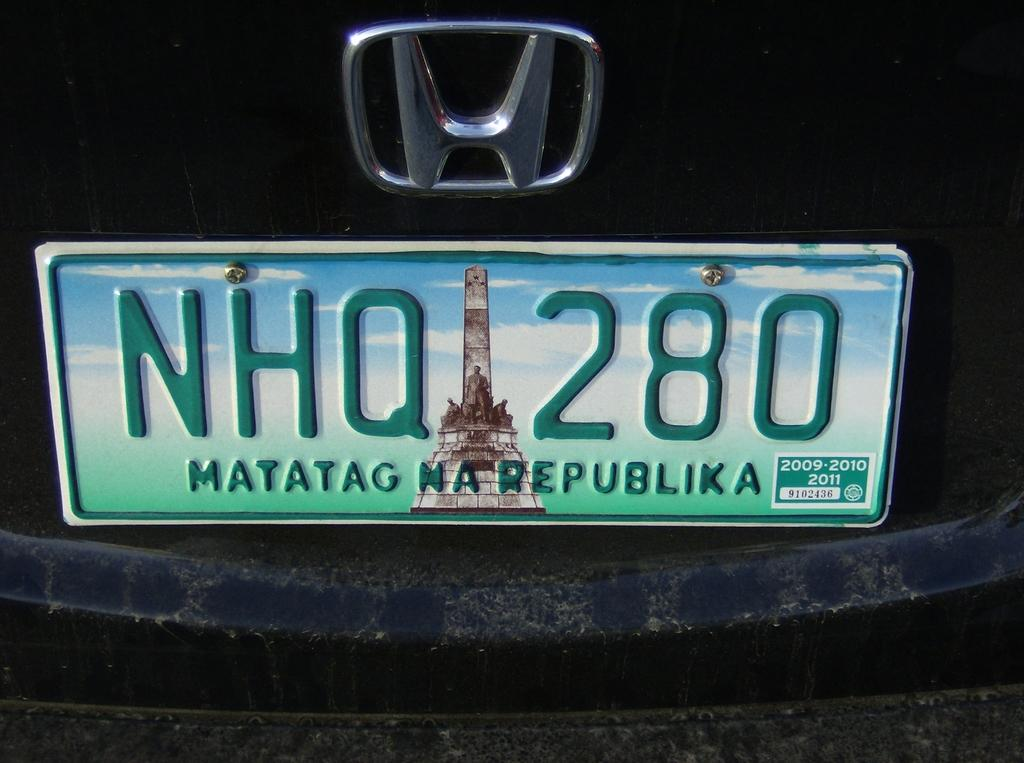Provide a one-sentence caption for the provided image. A license place of a Honda car reads NHQ 280. 